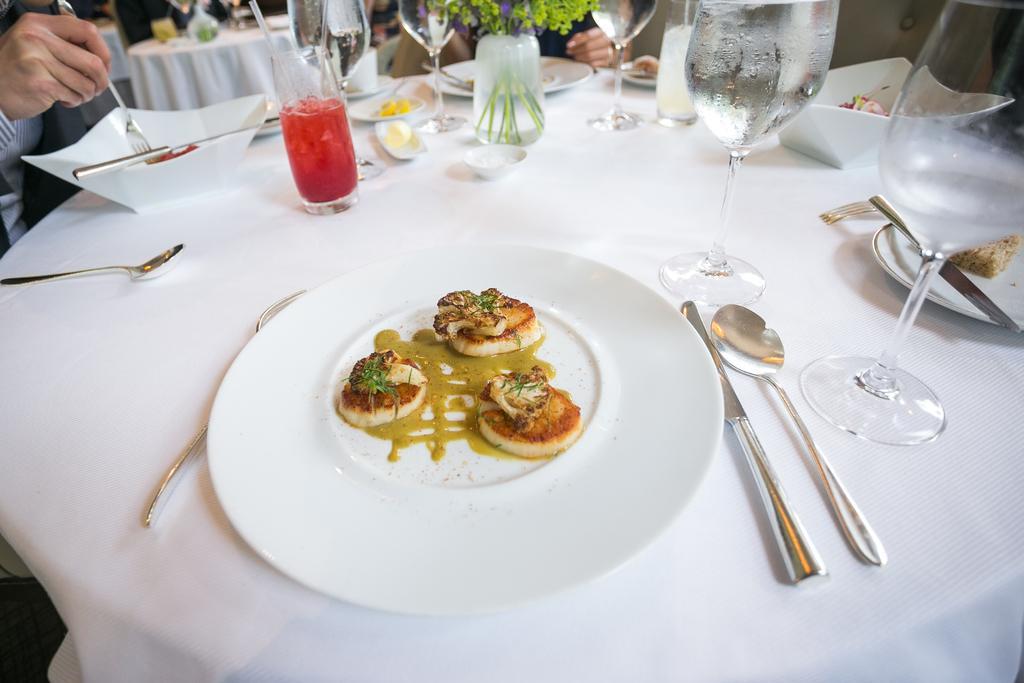Could you give a brief overview of what you see in this image? This is a table which is covered with a cloth, where a plate, a glass and spoons are kept on it. 